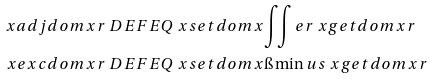<formula> <loc_0><loc_0><loc_500><loc_500>\ x a d j d o m { x } { r } & \ D E F E Q \ x s e t d o m { x } { \iint e r { \ x g e t d o m { x } } { r } } \\ \ x e x c d o m { x } { r } & \ D E F E Q \ x s e t d o m { x } { \i \min u s { \ x g e t d o m { x } } { r } }</formula> 